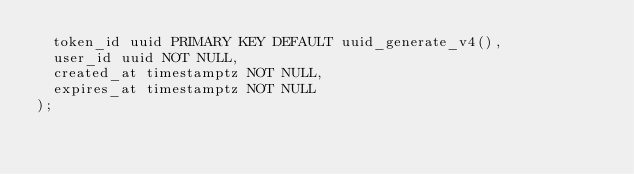<code> <loc_0><loc_0><loc_500><loc_500><_SQL_>  token_id uuid PRIMARY KEY DEFAULT uuid_generate_v4(),
  user_id uuid NOT NULL,
  created_at timestamptz NOT NULL,
  expires_at timestamptz NOT NULL
);
</code> 